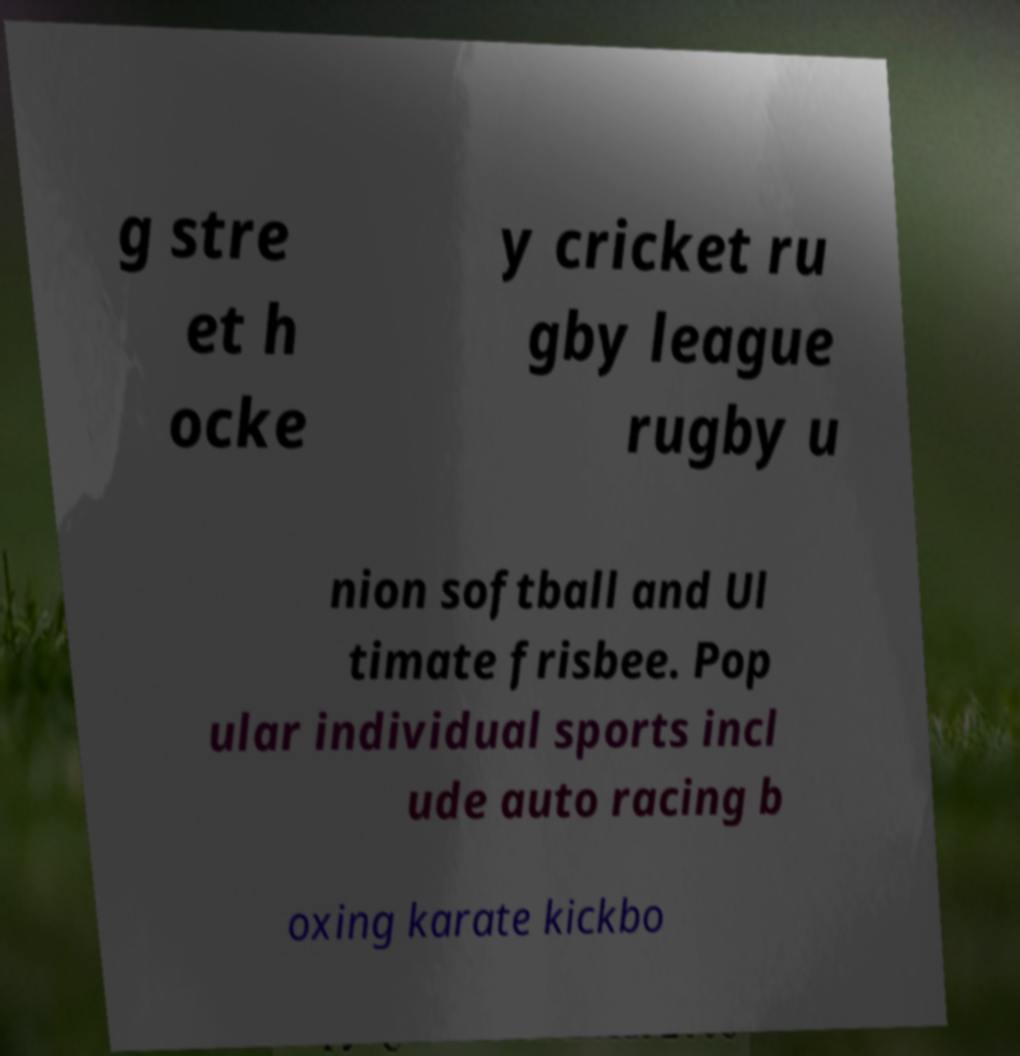Could you assist in decoding the text presented in this image and type it out clearly? g stre et h ocke y cricket ru gby league rugby u nion softball and Ul timate frisbee. Pop ular individual sports incl ude auto racing b oxing karate kickbo 